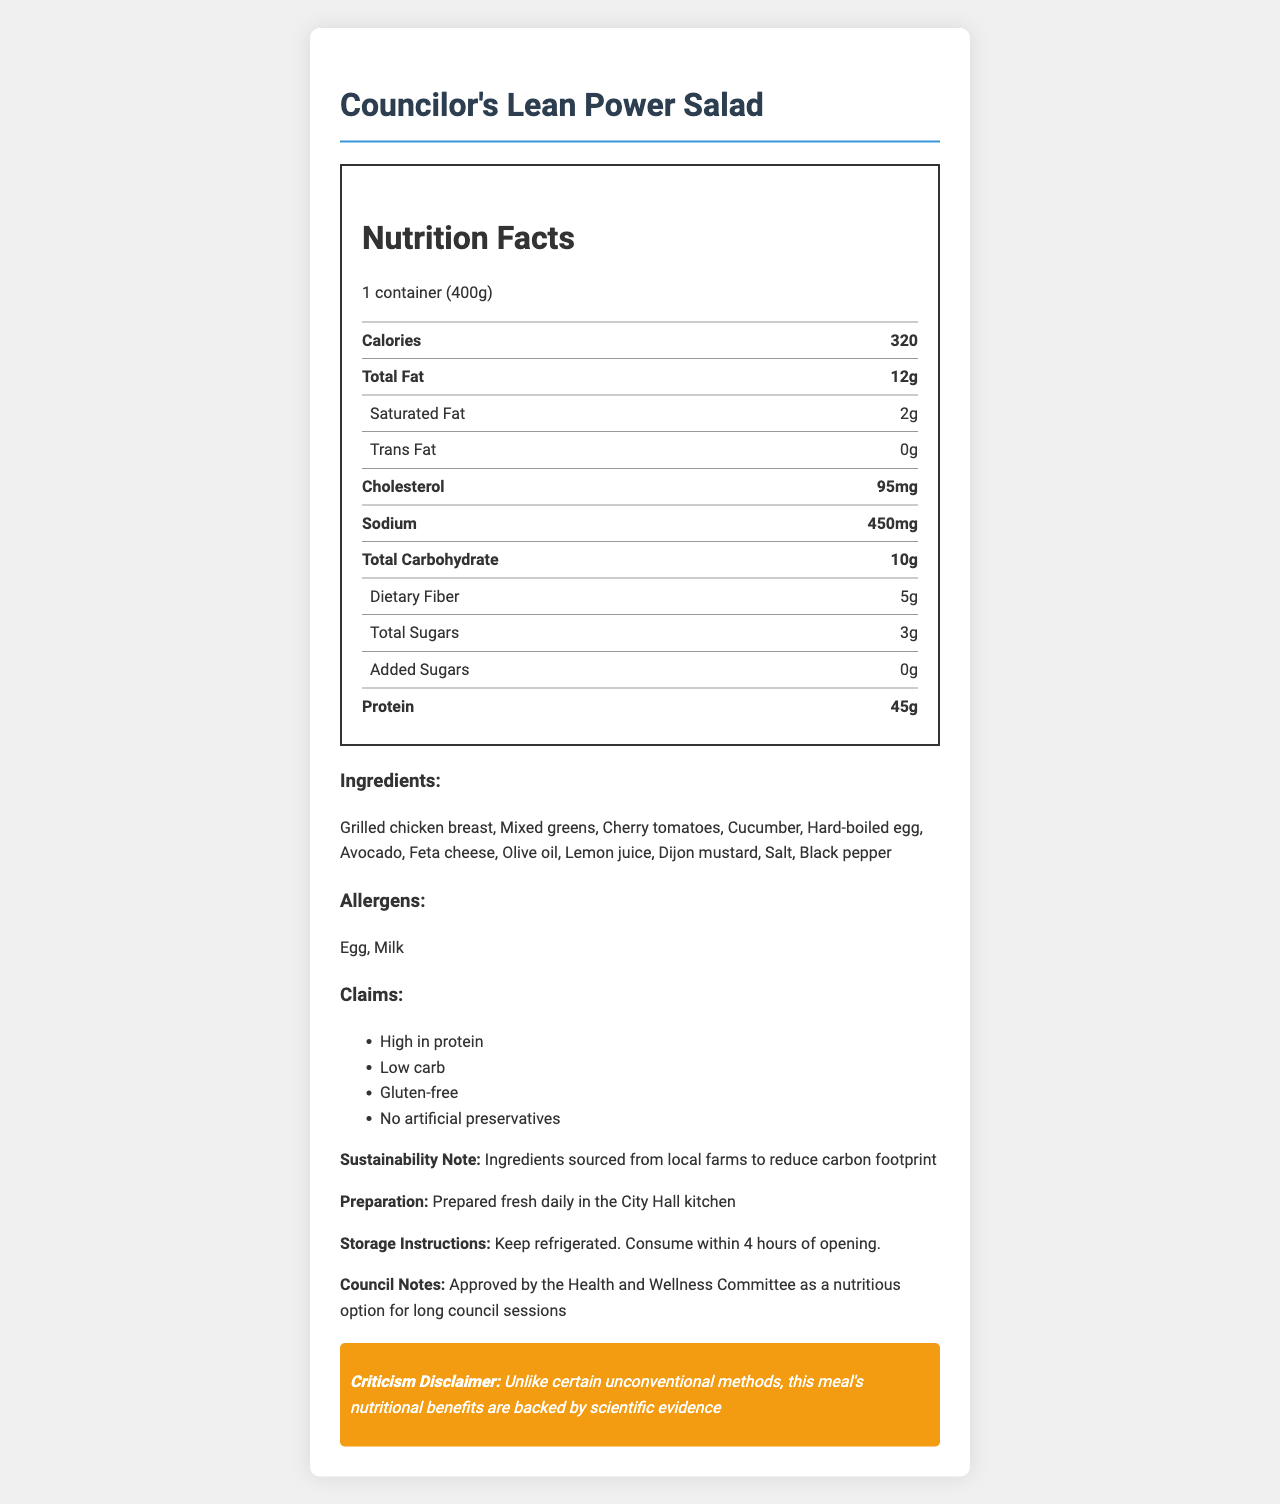what is the serving size of Councilor's Lean Power Salad? The serving size is explicitly mentioned at the top of the nutrition label: "1 container (400g)".
Answer: 1 container (400g) How many grams of protein does one serving of Councilor's Lean Power Salad contain? The amount of protein per serving is listed in the nutrition facts section as "Protein: 45g".
Answer: 45g What are the main sources of allergens in the Councilor's Lean Power Salad? The allergens section lists "Egg" and "Milk" as the main sources of allergens in this salad.
Answer: Egg, Milk How many grams of total carbohydrates are present in the salad? The total carbohydrates per serving are mentioned in the nutrition facts section as "Total Carbohydrate: 10g".
Answer: 10g Is the salad high in fiber? The dietary fiber content is 5g per serving, which is considered a good source of fiber.
Answer: Yes What is the calorie count per serving? The number of calories per serving is listed as "Calories: 320".
Answer: 320 calories Which vitamin is present in the highest percentage of daily value? The vitamin percentages are listed, with Vitamin C having the highest percentage at 30%.
Answer: Vitamin C (30%) Which claim is not made about the Councilor's Lean Power Salad? A. High in protein B. Low carb C. Contains gluten D. No artificial preservatives The claims section states: "High in protein", "Low carb", "Gluten-free", and "No artificial preservatives". Therefore, "Contains gluten" is not made as a claim.
Answer: C What is the sodium content of the salad? A. 350mg B. 450mg C. 550mg D. 650mg The sodium content is listed in the nutrition facts as "Sodium: 450mg".
Answer: B Does the Councilor's Lean Power Salad contain any trans fat? The nutrition facts section states that the amount of trans fat is 0g.
Answer: No Summarize the main idea of the document. The main idea is to provide comprehensive nutritional information about the salad to inform council members of its benefits and content.
Answer: The document describes the nutrition facts of the Councilor's Lean Power Salad, highlighting it as a high-protein, low-carb meal approved for city council meetings. It details the serving size, nutritional content, ingredients, allergens, claims, and preparation notes. Are there any artificial preservatives in the salad? The claims section specifically states "No artificial preservatives".
Answer: No Which of the following is not an ingredient in the salad? A. Grilled chicken breast B. Bacon strips C. Avocado D. Feta cheese The ingredients listed do not include "Bacon strips". Instead, they include "Grilled chicken breast", "Avocado", and "Feta cheese".
Answer: B How should the salad be stored after opening? The storage instructions specify to "Keep refrigerated. Consume within 4 hours of opening."
Answer: Keep refrigerated. Consume within 4 hours of opening. Who approved the salad as a nutritious option for long council sessions? This information is found in the council notes section which states "Approved by the Health and Wellness Committee as a nutritious option for long council sessions".
Answer: The Health and Wellness Committee What is the price of the Councilor's Lean Power Salad? The document does not provide any information regarding the price of the salad.
Answer: Not enough information 